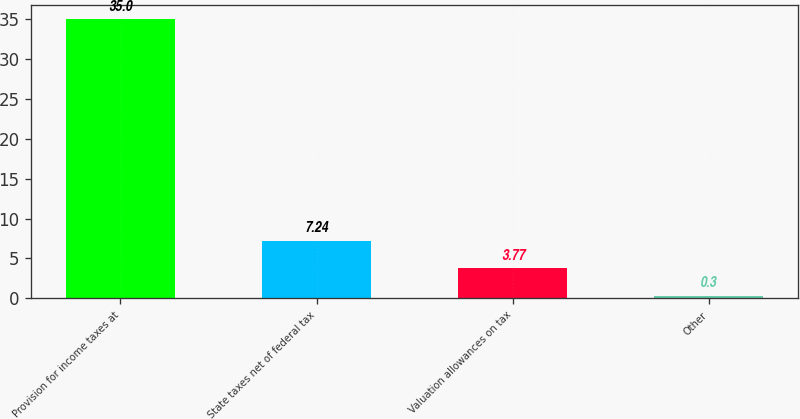Convert chart to OTSL. <chart><loc_0><loc_0><loc_500><loc_500><bar_chart><fcel>Provision for income taxes at<fcel>State taxes net of federal tax<fcel>Valuation allowances on tax<fcel>Other<nl><fcel>35<fcel>7.24<fcel>3.77<fcel>0.3<nl></chart> 